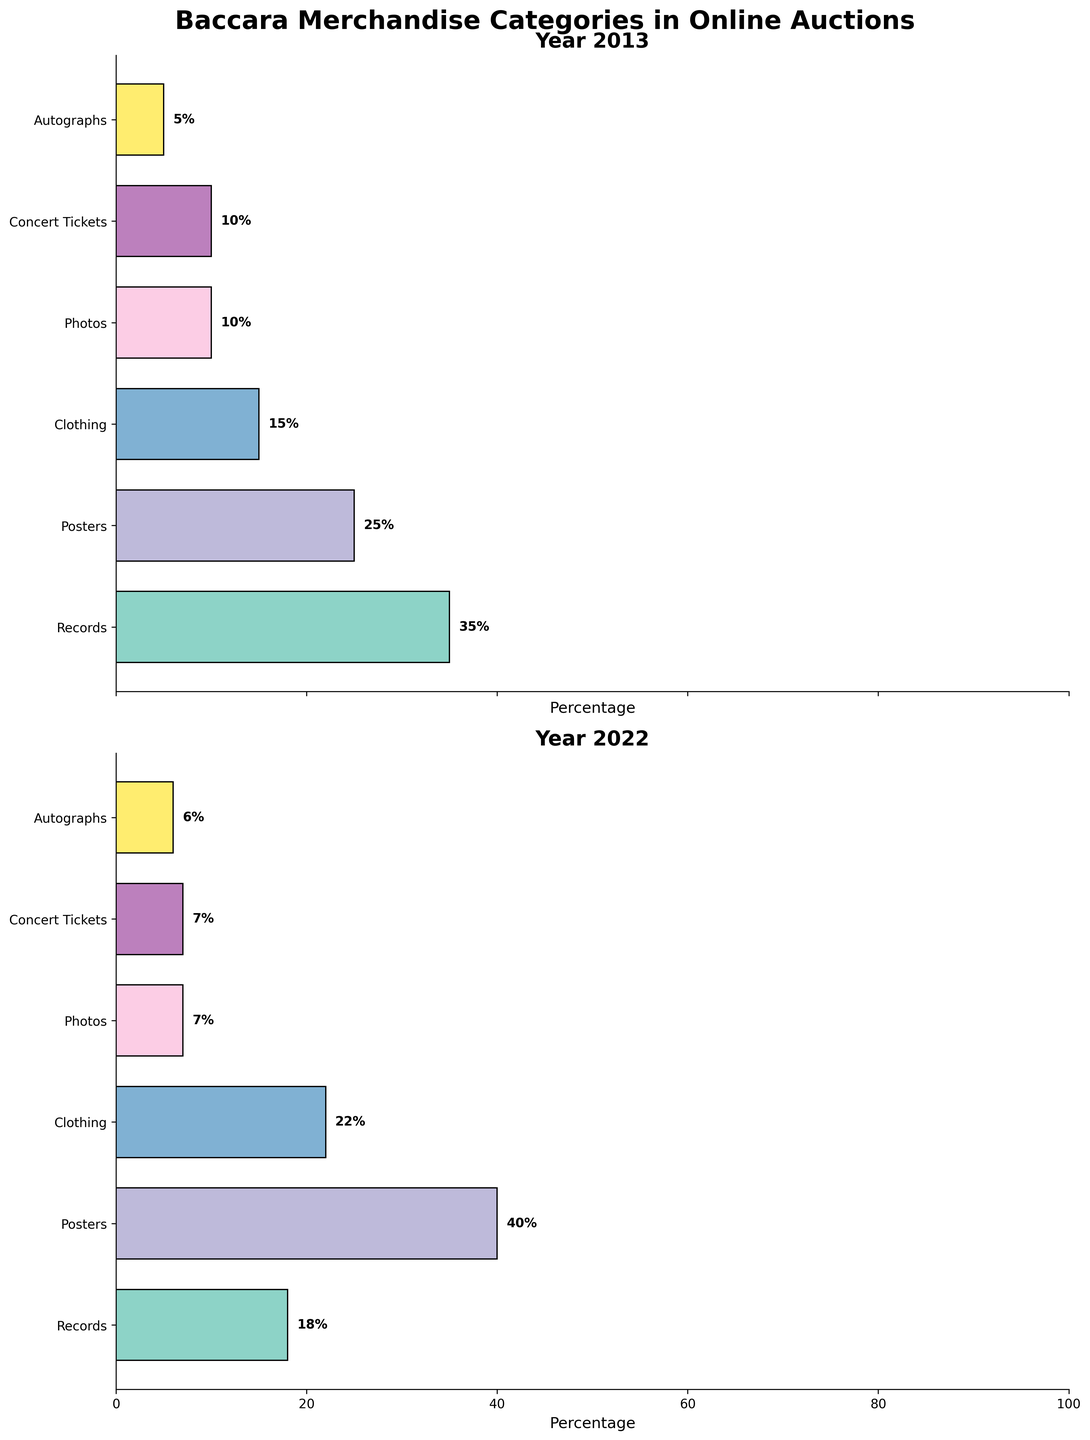What is the title of the figure? The title of the figure is written at the top of the figure and it is "Baccara Merchandise Categories in Online Auctions". This gives an overview of what the figure is about.
Answer: Baccara Merchandise Categories in Online Auctions What are the categories shown in the subplots? The categories are listed on the y-axis of both subplots. These categories are Records, Posters, Clothing, Photos, Concert Tickets, and Autographs.
Answer: Records, Posters, Clothing, Photos, Concert Tickets, Autographs In which year did Posters have the highest percentage? Looking at the bars representing Posters in both subplots, notice that the bar is longest in the subplot for the year 2022.
Answer: 2022 What is the percentage of Records in 2013? Examine the horizontal bar for Records in the 2013 subplot; it is labeled with the percentage value.
Answer: 35% What is the difference in the percentage of Records between the years 2013 and 2022? In the 2013 subplot, the percentage for Records is 35%. In the 2022 subplot, it is 18%. So, the difference is 35% - 18%.
Answer: 17% Which category shows the least percentage change between 2013 and 2022? Compare the percentage values of each category between the two years. Autographs show the values of 5% in 2013 and 6% in 2022, making this the smallest change.
Answer: Autographs In 2022, which category has the second highest percentage and what is it? Look at the percent values in the 2022 subplot and find the second longest bar. It is Clothing with 22%.
Answer: Clothing, 22% How did the percentage of Concert Tickets change from 2013 to 2022? Locate the bar for Concert Tickets for both years. It remained the same at 7% in both 2013 and 2022.
Answer: No change Between 2013 and 2022, which category increased the most in percentage terms? Compare the difference in the bars for each category. Posters went from 25% in 2013 to 40% in 2022, an increase of 15%, which is the highest.
Answer: Posters 